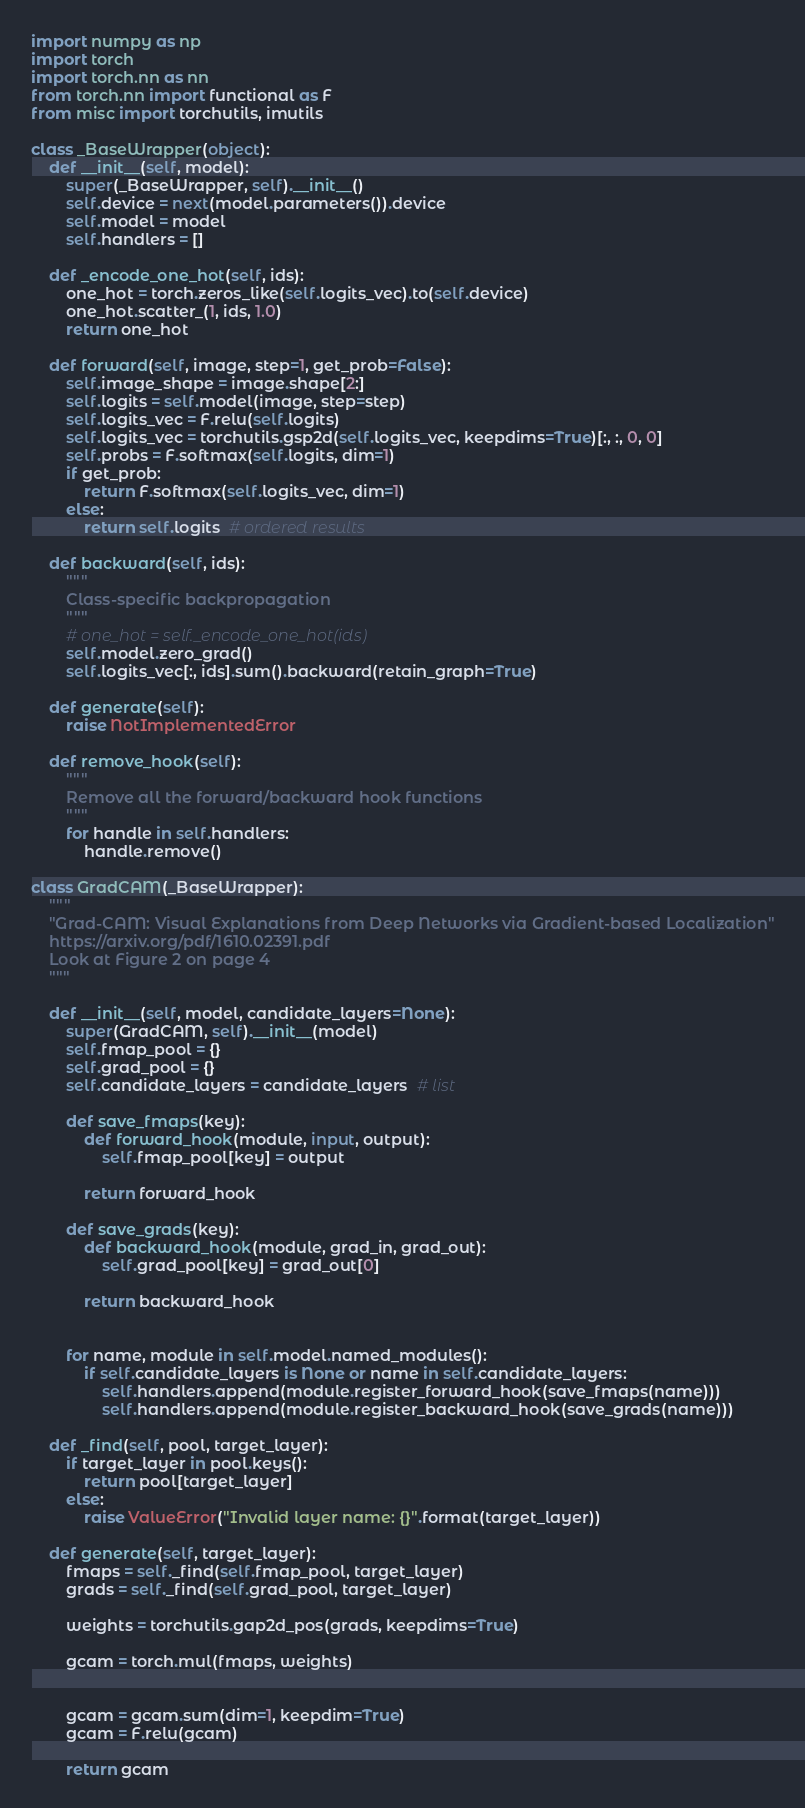<code> <loc_0><loc_0><loc_500><loc_500><_Python_>
import numpy as np
import torch
import torch.nn as nn
from torch.nn import functional as F
from misc import torchutils, imutils

class _BaseWrapper(object):
    def __init__(self, model):
        super(_BaseWrapper, self).__init__()
        self.device = next(model.parameters()).device
        self.model = model
        self.handlers = []  

    def _encode_one_hot(self, ids):
        one_hot = torch.zeros_like(self.logits_vec).to(self.device)
        one_hot.scatter_(1, ids, 1.0)
        return one_hot

    def forward(self, image, step=1, get_prob=False):
        self.image_shape = image.shape[2:]
        self.logits = self.model(image, step=step)
        self.logits_vec = F.relu(self.logits)
        self.logits_vec = torchutils.gsp2d(self.logits_vec, keepdims=True)[:, :, 0, 0]
        self.probs = F.softmax(self.logits, dim=1)
        if get_prob:
            return F.softmax(self.logits_vec, dim=1)
        else:
            return self.logits  # ordered results

    def backward(self, ids):
        """
        Class-specific backpropagation
        """
        # one_hot = self._encode_one_hot(ids)
        self.model.zero_grad()
        self.logits_vec[:, ids].sum().backward(retain_graph=True)

    def generate(self):
        raise NotImplementedError

    def remove_hook(self):
        """
        Remove all the forward/backward hook functions
        """
        for handle in self.handlers:
            handle.remove()

class GradCAM(_BaseWrapper):
    """
    "Grad-CAM: Visual Explanations from Deep Networks via Gradient-based Localization"
    https://arxiv.org/pdf/1610.02391.pdf
    Look at Figure 2 on page 4
    """

    def __init__(self, model, candidate_layers=None):
        super(GradCAM, self).__init__(model)
        self.fmap_pool = {}
        self.grad_pool = {}
        self.candidate_layers = candidate_layers  # list

        def save_fmaps(key):
            def forward_hook(module, input, output):
                self.fmap_pool[key] = output

            return forward_hook

        def save_grads(key):
            def backward_hook(module, grad_in, grad_out):
                self.grad_pool[key] = grad_out[0]

            return backward_hook

        
        for name, module in self.model.named_modules():
            if self.candidate_layers is None or name in self.candidate_layers:
                self.handlers.append(module.register_forward_hook(save_fmaps(name)))
                self.handlers.append(module.register_backward_hook(save_grads(name)))

    def _find(self, pool, target_layer):
        if target_layer in pool.keys():
            return pool[target_layer]
        else:
            raise ValueError("Invalid layer name: {}".format(target_layer))

    def generate(self, target_layer):
        fmaps = self._find(self.fmap_pool, target_layer)
        grads = self._find(self.grad_pool, target_layer)

        weights = torchutils.gap2d_pos(grads, keepdims=True)

        gcam = torch.mul(fmaps, weights)


        gcam = gcam.sum(dim=1, keepdim=True)
        gcam = F.relu(gcam)

        return gcam
</code> 